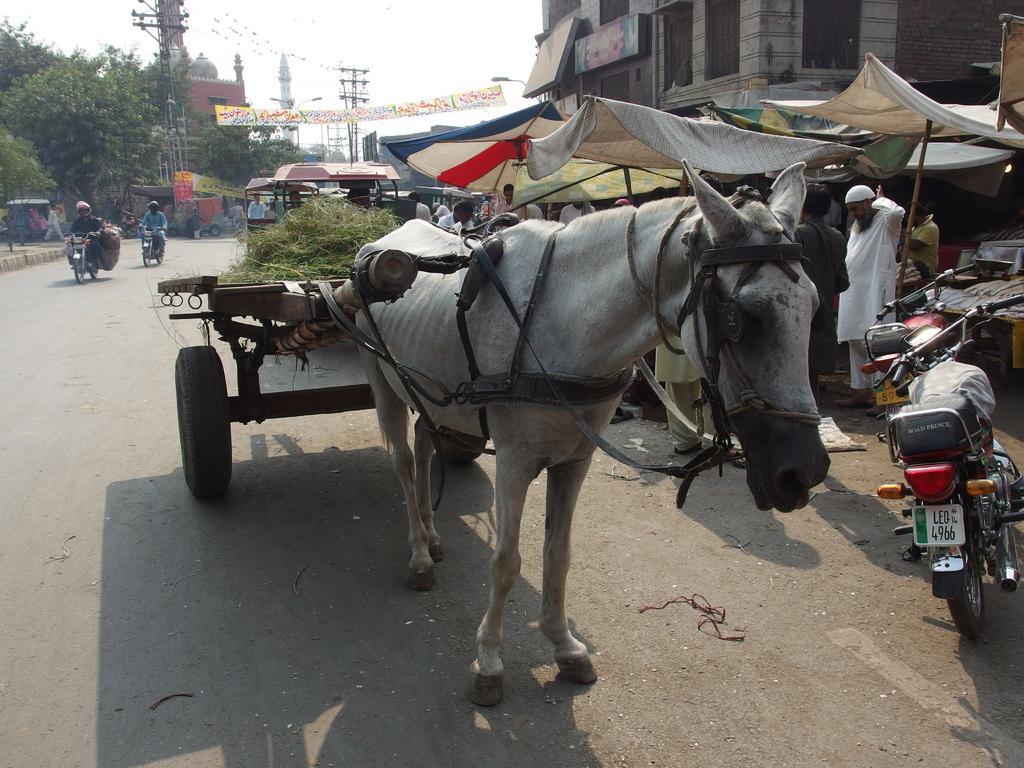Describe this image in one or two sentences. In this picture I can see buildings, trees and I can see a horse and a cart with grass on it and I can see couple of them moving on motorcycles and few are standing and I can see a motorcycle parked and I can see tents and couple of poles and I can see a banner and a cloudy sky. 